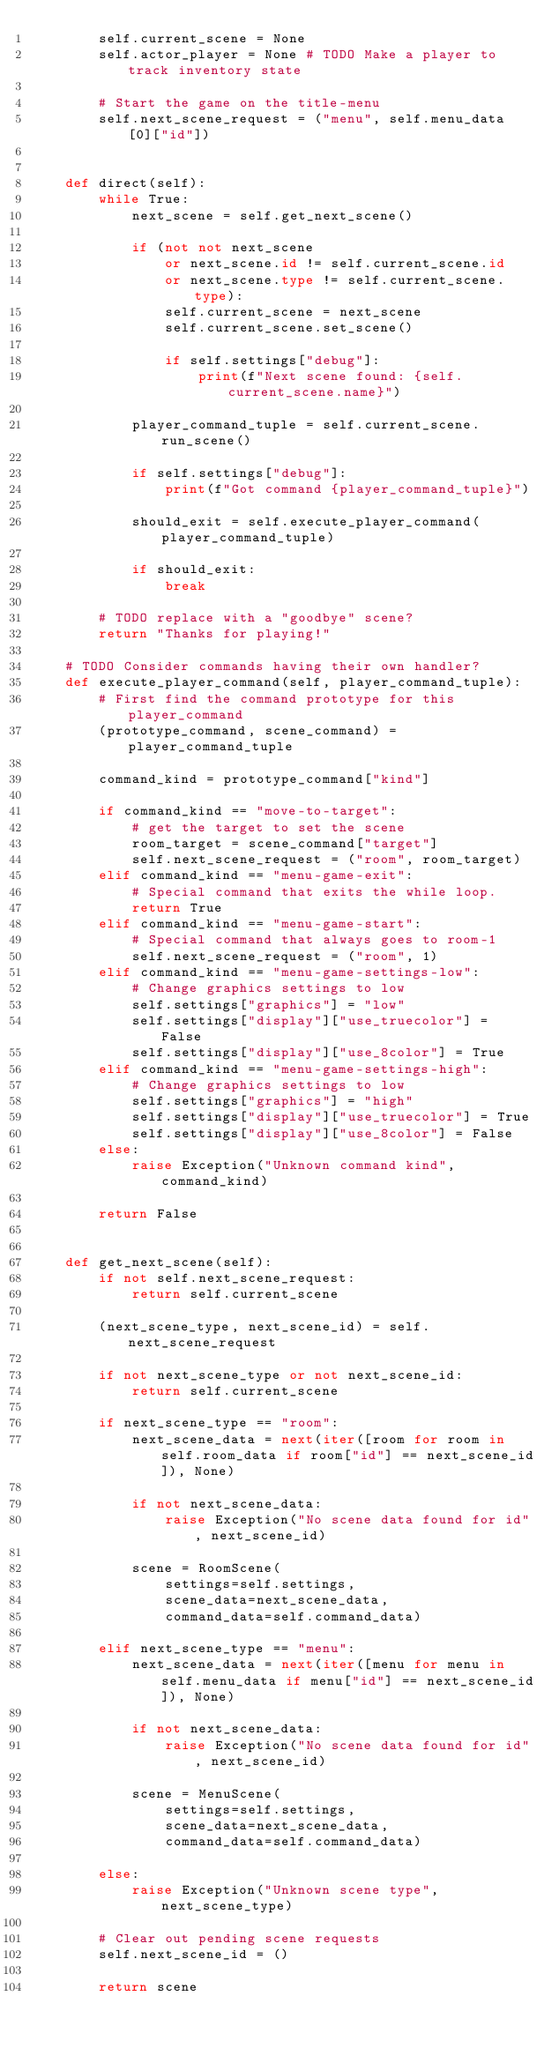Convert code to text. <code><loc_0><loc_0><loc_500><loc_500><_Python_>        self.current_scene = None
        self.actor_player = None # TODO Make a player to track inventory state

        # Start the game on the title-menu
        self.next_scene_request = ("menu", self.menu_data[0]["id"])


    def direct(self):
        while True:
            next_scene = self.get_next_scene()

            if (not not next_scene
                or next_scene.id != self.current_scene.id
                or next_scene.type != self.current_scene.type):
                self.current_scene = next_scene
                self.current_scene.set_scene()

                if self.settings["debug"]:
                    print(f"Next scene found: {self.current_scene.name}")

            player_command_tuple = self.current_scene.run_scene()

            if self.settings["debug"]:
                print(f"Got command {player_command_tuple}")

            should_exit = self.execute_player_command(player_command_tuple)

            if should_exit:
                break

        # TODO replace with a "goodbye" scene?
        return "Thanks for playing!"

    # TODO Consider commands having their own handler?
    def execute_player_command(self, player_command_tuple):
        # First find the command prototype for this player_command
        (prototype_command, scene_command) = player_command_tuple

        command_kind = prototype_command["kind"]

        if command_kind == "move-to-target":
            # get the target to set the scene
            room_target = scene_command["target"]
            self.next_scene_request = ("room", room_target)
        elif command_kind == "menu-game-exit":
            # Special command that exits the while loop.
            return True
        elif command_kind == "menu-game-start":
            # Special command that always goes to room-1
            self.next_scene_request = ("room", 1)
        elif command_kind == "menu-game-settings-low":
            # Change graphics settings to low
            self.settings["graphics"] = "low"
            self.settings["display"]["use_truecolor"] = False
            self.settings["display"]["use_8color"] = True
        elif command_kind == "menu-game-settings-high":
            # Change graphics settings to low
            self.settings["graphics"] = "high"
            self.settings["display"]["use_truecolor"] = True
            self.settings["display"]["use_8color"] = False
        else:
            raise Exception("Unknown command kind", command_kind)

        return False


    def get_next_scene(self):
        if not self.next_scene_request:
            return self.current_scene

        (next_scene_type, next_scene_id) = self.next_scene_request

        if not next_scene_type or not next_scene_id:
            return self.current_scene

        if next_scene_type == "room":
            next_scene_data = next(iter([room for room in self.room_data if room["id"] == next_scene_id]), None)

            if not next_scene_data:
                raise Exception("No scene data found for id", next_scene_id)

            scene = RoomScene(
                settings=self.settings,
                scene_data=next_scene_data,
                command_data=self.command_data)

        elif next_scene_type == "menu":
            next_scene_data = next(iter([menu for menu in self.menu_data if menu["id"] == next_scene_id]), None)

            if not next_scene_data:
                raise Exception("No scene data found for id", next_scene_id)

            scene = MenuScene(
                settings=self.settings,
                scene_data=next_scene_data,
                command_data=self.command_data)

        else:
            raise Exception("Unknown scene type", next_scene_type)

        # Clear out pending scene requests
        self.next_scene_id = ()

        return scene
</code> 